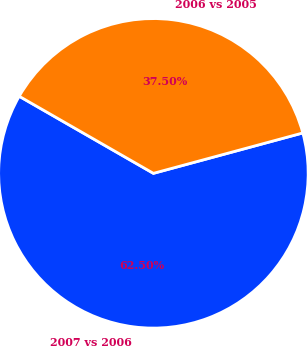<chart> <loc_0><loc_0><loc_500><loc_500><pie_chart><fcel>2007 vs 2006<fcel>2006 vs 2005<nl><fcel>62.5%<fcel>37.5%<nl></chart> 